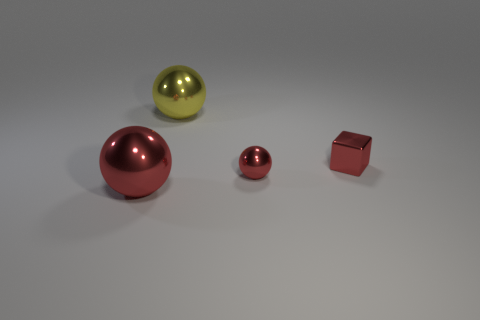Add 4 big metal balls. How many objects exist? 8 Subtract all blocks. How many objects are left? 3 Add 4 small cyan shiny spheres. How many small cyan shiny spheres exist? 4 Subtract 2 red balls. How many objects are left? 2 Subtract all tiny blocks. Subtract all small red blocks. How many objects are left? 2 Add 2 shiny spheres. How many shiny spheres are left? 5 